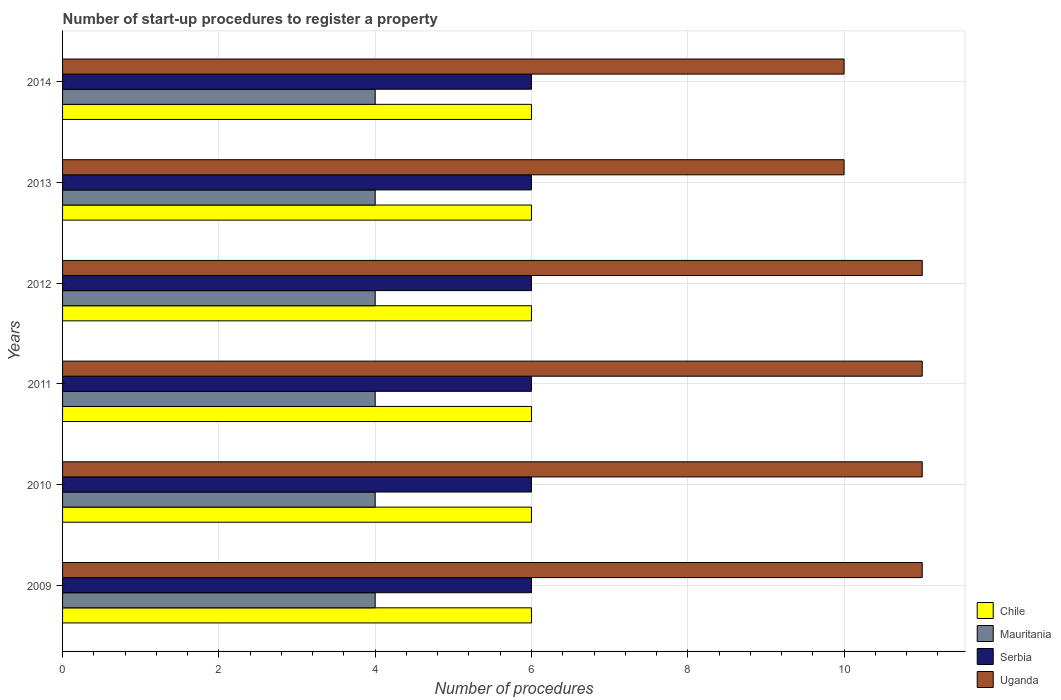How many groups of bars are there?
Keep it short and to the point. 6. Are the number of bars on each tick of the Y-axis equal?
Your answer should be very brief. Yes. How many bars are there on the 6th tick from the bottom?
Keep it short and to the point. 4. In how many cases, is the number of bars for a given year not equal to the number of legend labels?
Your answer should be very brief. 0. What is the number of procedures required to register a property in Mauritania in 2013?
Your answer should be very brief. 4. Across all years, what is the maximum number of procedures required to register a property in Uganda?
Your response must be concise. 11. Across all years, what is the minimum number of procedures required to register a property in Uganda?
Offer a terse response. 10. What is the total number of procedures required to register a property in Mauritania in the graph?
Offer a terse response. 24. What is the difference between the number of procedures required to register a property in Mauritania in 2011 and that in 2013?
Your answer should be compact. 0. What is the difference between the number of procedures required to register a property in Serbia in 2009 and the number of procedures required to register a property in Uganda in 2013?
Provide a succinct answer. -4. What is the average number of procedures required to register a property in Chile per year?
Provide a succinct answer. 6. In the year 2014, what is the difference between the number of procedures required to register a property in Chile and number of procedures required to register a property in Uganda?
Make the answer very short. -4. Is the difference between the number of procedures required to register a property in Chile in 2009 and 2012 greater than the difference between the number of procedures required to register a property in Uganda in 2009 and 2012?
Your response must be concise. No. What is the difference between the highest and the lowest number of procedures required to register a property in Uganda?
Make the answer very short. 1. Is the sum of the number of procedures required to register a property in Uganda in 2011 and 2013 greater than the maximum number of procedures required to register a property in Serbia across all years?
Provide a short and direct response. Yes. Is it the case that in every year, the sum of the number of procedures required to register a property in Serbia and number of procedures required to register a property in Chile is greater than the sum of number of procedures required to register a property in Mauritania and number of procedures required to register a property in Uganda?
Your answer should be very brief. No. What does the 1st bar from the top in 2011 represents?
Offer a terse response. Uganda. What does the 3rd bar from the bottom in 2009 represents?
Offer a terse response. Serbia. How many bars are there?
Keep it short and to the point. 24. Are all the bars in the graph horizontal?
Provide a short and direct response. Yes. Does the graph contain any zero values?
Your response must be concise. No. Does the graph contain grids?
Ensure brevity in your answer.  Yes. What is the title of the graph?
Offer a very short reply. Number of start-up procedures to register a property. What is the label or title of the X-axis?
Provide a short and direct response. Number of procedures. What is the Number of procedures in Chile in 2009?
Provide a short and direct response. 6. What is the Number of procedures of Serbia in 2009?
Make the answer very short. 6. What is the Number of procedures of Uganda in 2009?
Offer a very short reply. 11. What is the Number of procedures in Chile in 2010?
Keep it short and to the point. 6. What is the Number of procedures in Serbia in 2010?
Offer a terse response. 6. What is the Number of procedures in Chile in 2011?
Your answer should be very brief. 6. What is the Number of procedures in Serbia in 2011?
Give a very brief answer. 6. What is the Number of procedures of Uganda in 2011?
Offer a very short reply. 11. What is the Number of procedures of Chile in 2012?
Offer a very short reply. 6. What is the Number of procedures in Chile in 2013?
Your answer should be very brief. 6. What is the Number of procedures of Mauritania in 2013?
Keep it short and to the point. 4. What is the Number of procedures of Serbia in 2013?
Offer a terse response. 6. What is the Number of procedures of Uganda in 2013?
Provide a succinct answer. 10. What is the Number of procedures in Mauritania in 2014?
Offer a terse response. 4. What is the Number of procedures in Serbia in 2014?
Provide a succinct answer. 6. What is the Number of procedures in Uganda in 2014?
Your response must be concise. 10. Across all years, what is the maximum Number of procedures in Chile?
Offer a terse response. 6. Across all years, what is the maximum Number of procedures in Serbia?
Offer a terse response. 6. Across all years, what is the minimum Number of procedures in Chile?
Keep it short and to the point. 6. Across all years, what is the minimum Number of procedures in Mauritania?
Offer a very short reply. 4. What is the total Number of procedures of Chile in the graph?
Provide a succinct answer. 36. What is the total Number of procedures of Serbia in the graph?
Your response must be concise. 36. What is the total Number of procedures of Uganda in the graph?
Give a very brief answer. 64. What is the difference between the Number of procedures of Uganda in 2009 and that in 2010?
Provide a succinct answer. 0. What is the difference between the Number of procedures in Mauritania in 2009 and that in 2011?
Keep it short and to the point. 0. What is the difference between the Number of procedures in Mauritania in 2009 and that in 2012?
Your response must be concise. 0. What is the difference between the Number of procedures of Serbia in 2009 and that in 2012?
Keep it short and to the point. 0. What is the difference between the Number of procedures of Chile in 2009 and that in 2013?
Offer a very short reply. 0. What is the difference between the Number of procedures of Chile in 2009 and that in 2014?
Give a very brief answer. 0. What is the difference between the Number of procedures in Serbia in 2009 and that in 2014?
Offer a very short reply. 0. What is the difference between the Number of procedures in Uganda in 2009 and that in 2014?
Offer a very short reply. 1. What is the difference between the Number of procedures in Chile in 2010 and that in 2011?
Keep it short and to the point. 0. What is the difference between the Number of procedures of Serbia in 2010 and that in 2011?
Ensure brevity in your answer.  0. What is the difference between the Number of procedures of Uganda in 2010 and that in 2011?
Your response must be concise. 0. What is the difference between the Number of procedures of Chile in 2010 and that in 2012?
Offer a very short reply. 0. What is the difference between the Number of procedures of Chile in 2010 and that in 2013?
Your response must be concise. 0. What is the difference between the Number of procedures in Serbia in 2010 and that in 2013?
Provide a short and direct response. 0. What is the difference between the Number of procedures of Chile in 2010 and that in 2014?
Provide a short and direct response. 0. What is the difference between the Number of procedures of Mauritania in 2010 and that in 2014?
Offer a terse response. 0. What is the difference between the Number of procedures of Chile in 2011 and that in 2012?
Give a very brief answer. 0. What is the difference between the Number of procedures of Mauritania in 2011 and that in 2012?
Your answer should be very brief. 0. What is the difference between the Number of procedures in Uganda in 2011 and that in 2012?
Provide a succinct answer. 0. What is the difference between the Number of procedures of Mauritania in 2011 and that in 2013?
Offer a terse response. 0. What is the difference between the Number of procedures of Uganda in 2011 and that in 2013?
Offer a terse response. 1. What is the difference between the Number of procedures of Mauritania in 2011 and that in 2014?
Ensure brevity in your answer.  0. What is the difference between the Number of procedures in Mauritania in 2012 and that in 2013?
Provide a short and direct response. 0. What is the difference between the Number of procedures in Serbia in 2012 and that in 2013?
Your answer should be compact. 0. What is the difference between the Number of procedures of Uganda in 2012 and that in 2013?
Offer a very short reply. 1. What is the difference between the Number of procedures in Chile in 2012 and that in 2014?
Your answer should be compact. 0. What is the difference between the Number of procedures of Mauritania in 2013 and that in 2014?
Provide a succinct answer. 0. What is the difference between the Number of procedures of Serbia in 2013 and that in 2014?
Your answer should be compact. 0. What is the difference between the Number of procedures of Uganda in 2013 and that in 2014?
Provide a short and direct response. 0. What is the difference between the Number of procedures of Chile in 2009 and the Number of procedures of Mauritania in 2010?
Offer a very short reply. 2. What is the difference between the Number of procedures in Chile in 2009 and the Number of procedures in Serbia in 2010?
Your answer should be very brief. 0. What is the difference between the Number of procedures of Chile in 2009 and the Number of procedures of Uganda in 2010?
Offer a terse response. -5. What is the difference between the Number of procedures of Mauritania in 2009 and the Number of procedures of Serbia in 2010?
Provide a short and direct response. -2. What is the difference between the Number of procedures in Mauritania in 2009 and the Number of procedures in Serbia in 2011?
Your answer should be compact. -2. What is the difference between the Number of procedures in Mauritania in 2009 and the Number of procedures in Uganda in 2011?
Keep it short and to the point. -7. What is the difference between the Number of procedures in Chile in 2009 and the Number of procedures in Mauritania in 2012?
Your answer should be compact. 2. What is the difference between the Number of procedures in Chile in 2009 and the Number of procedures in Serbia in 2012?
Provide a short and direct response. 0. What is the difference between the Number of procedures of Chile in 2009 and the Number of procedures of Uganda in 2012?
Keep it short and to the point. -5. What is the difference between the Number of procedures in Mauritania in 2009 and the Number of procedures in Serbia in 2012?
Ensure brevity in your answer.  -2. What is the difference between the Number of procedures of Serbia in 2009 and the Number of procedures of Uganda in 2012?
Ensure brevity in your answer.  -5. What is the difference between the Number of procedures in Mauritania in 2009 and the Number of procedures in Serbia in 2013?
Make the answer very short. -2. What is the difference between the Number of procedures in Serbia in 2009 and the Number of procedures in Uganda in 2013?
Offer a terse response. -4. What is the difference between the Number of procedures of Mauritania in 2009 and the Number of procedures of Uganda in 2014?
Keep it short and to the point. -6. What is the difference between the Number of procedures in Serbia in 2009 and the Number of procedures in Uganda in 2014?
Provide a succinct answer. -4. What is the difference between the Number of procedures of Chile in 2010 and the Number of procedures of Mauritania in 2011?
Ensure brevity in your answer.  2. What is the difference between the Number of procedures in Mauritania in 2010 and the Number of procedures in Serbia in 2011?
Offer a terse response. -2. What is the difference between the Number of procedures in Serbia in 2010 and the Number of procedures in Uganda in 2011?
Your answer should be compact. -5. What is the difference between the Number of procedures in Chile in 2010 and the Number of procedures in Serbia in 2012?
Give a very brief answer. 0. What is the difference between the Number of procedures of Chile in 2010 and the Number of procedures of Uganda in 2012?
Your response must be concise. -5. What is the difference between the Number of procedures in Chile in 2010 and the Number of procedures in Mauritania in 2013?
Offer a terse response. 2. What is the difference between the Number of procedures of Chile in 2010 and the Number of procedures of Uganda in 2013?
Offer a terse response. -4. What is the difference between the Number of procedures of Mauritania in 2010 and the Number of procedures of Uganda in 2013?
Offer a terse response. -6. What is the difference between the Number of procedures of Serbia in 2010 and the Number of procedures of Uganda in 2013?
Provide a succinct answer. -4. What is the difference between the Number of procedures in Chile in 2010 and the Number of procedures in Uganda in 2014?
Provide a short and direct response. -4. What is the difference between the Number of procedures in Mauritania in 2010 and the Number of procedures in Serbia in 2014?
Provide a succinct answer. -2. What is the difference between the Number of procedures in Mauritania in 2010 and the Number of procedures in Uganda in 2014?
Give a very brief answer. -6. What is the difference between the Number of procedures in Chile in 2011 and the Number of procedures in Serbia in 2012?
Your answer should be compact. 0. What is the difference between the Number of procedures in Mauritania in 2011 and the Number of procedures in Serbia in 2012?
Keep it short and to the point. -2. What is the difference between the Number of procedures of Chile in 2011 and the Number of procedures of Serbia in 2013?
Your answer should be very brief. 0. What is the difference between the Number of procedures in Mauritania in 2011 and the Number of procedures in Serbia in 2013?
Offer a terse response. -2. What is the difference between the Number of procedures in Serbia in 2011 and the Number of procedures in Uganda in 2013?
Offer a terse response. -4. What is the difference between the Number of procedures in Chile in 2011 and the Number of procedures in Mauritania in 2014?
Your answer should be compact. 2. What is the difference between the Number of procedures in Chile in 2011 and the Number of procedures in Uganda in 2014?
Provide a succinct answer. -4. What is the difference between the Number of procedures of Mauritania in 2011 and the Number of procedures of Serbia in 2014?
Offer a very short reply. -2. What is the difference between the Number of procedures in Mauritania in 2011 and the Number of procedures in Uganda in 2014?
Your answer should be compact. -6. What is the difference between the Number of procedures in Serbia in 2011 and the Number of procedures in Uganda in 2014?
Your response must be concise. -4. What is the difference between the Number of procedures in Chile in 2012 and the Number of procedures in Mauritania in 2013?
Give a very brief answer. 2. What is the difference between the Number of procedures in Chile in 2012 and the Number of procedures in Serbia in 2013?
Your answer should be very brief. 0. What is the difference between the Number of procedures of Mauritania in 2012 and the Number of procedures of Serbia in 2013?
Provide a short and direct response. -2. What is the difference between the Number of procedures of Serbia in 2012 and the Number of procedures of Uganda in 2013?
Ensure brevity in your answer.  -4. What is the difference between the Number of procedures in Chile in 2012 and the Number of procedures in Uganda in 2014?
Ensure brevity in your answer.  -4. What is the difference between the Number of procedures in Mauritania in 2012 and the Number of procedures in Serbia in 2014?
Your answer should be compact. -2. What is the difference between the Number of procedures in Mauritania in 2012 and the Number of procedures in Uganda in 2014?
Your answer should be compact. -6. What is the difference between the Number of procedures in Chile in 2013 and the Number of procedures in Serbia in 2014?
Provide a short and direct response. 0. What is the difference between the Number of procedures of Chile in 2013 and the Number of procedures of Uganda in 2014?
Offer a terse response. -4. What is the difference between the Number of procedures of Mauritania in 2013 and the Number of procedures of Uganda in 2014?
Give a very brief answer. -6. What is the average Number of procedures in Uganda per year?
Provide a succinct answer. 10.67. In the year 2009, what is the difference between the Number of procedures in Chile and Number of procedures in Mauritania?
Your response must be concise. 2. In the year 2009, what is the difference between the Number of procedures in Chile and Number of procedures in Serbia?
Offer a very short reply. 0. In the year 2010, what is the difference between the Number of procedures of Chile and Number of procedures of Serbia?
Give a very brief answer. 0. In the year 2010, what is the difference between the Number of procedures in Mauritania and Number of procedures in Serbia?
Your answer should be compact. -2. In the year 2010, what is the difference between the Number of procedures in Serbia and Number of procedures in Uganda?
Provide a succinct answer. -5. In the year 2011, what is the difference between the Number of procedures in Chile and Number of procedures in Mauritania?
Ensure brevity in your answer.  2. In the year 2011, what is the difference between the Number of procedures of Chile and Number of procedures of Uganda?
Provide a succinct answer. -5. In the year 2011, what is the difference between the Number of procedures in Serbia and Number of procedures in Uganda?
Offer a terse response. -5. In the year 2012, what is the difference between the Number of procedures in Chile and Number of procedures in Mauritania?
Ensure brevity in your answer.  2. In the year 2012, what is the difference between the Number of procedures in Chile and Number of procedures in Serbia?
Provide a short and direct response. 0. In the year 2012, what is the difference between the Number of procedures of Mauritania and Number of procedures of Uganda?
Provide a short and direct response. -7. In the year 2012, what is the difference between the Number of procedures of Serbia and Number of procedures of Uganda?
Keep it short and to the point. -5. In the year 2013, what is the difference between the Number of procedures in Chile and Number of procedures in Serbia?
Provide a short and direct response. 0. In the year 2013, what is the difference between the Number of procedures of Chile and Number of procedures of Uganda?
Your answer should be compact. -4. In the year 2013, what is the difference between the Number of procedures in Mauritania and Number of procedures in Serbia?
Give a very brief answer. -2. In the year 2013, what is the difference between the Number of procedures in Serbia and Number of procedures in Uganda?
Keep it short and to the point. -4. What is the ratio of the Number of procedures in Mauritania in 2009 to that in 2010?
Your response must be concise. 1. What is the ratio of the Number of procedures in Serbia in 2009 to that in 2010?
Keep it short and to the point. 1. What is the ratio of the Number of procedures in Chile in 2009 to that in 2011?
Give a very brief answer. 1. What is the ratio of the Number of procedures in Mauritania in 2009 to that in 2011?
Keep it short and to the point. 1. What is the ratio of the Number of procedures of Uganda in 2009 to that in 2011?
Keep it short and to the point. 1. What is the ratio of the Number of procedures in Chile in 2009 to that in 2012?
Offer a very short reply. 1. What is the ratio of the Number of procedures of Serbia in 2009 to that in 2012?
Your response must be concise. 1. What is the ratio of the Number of procedures of Uganda in 2009 to that in 2012?
Offer a very short reply. 1. What is the ratio of the Number of procedures of Chile in 2009 to that in 2013?
Your answer should be very brief. 1. What is the ratio of the Number of procedures in Mauritania in 2009 to that in 2013?
Make the answer very short. 1. What is the ratio of the Number of procedures of Serbia in 2009 to that in 2013?
Your answer should be very brief. 1. What is the ratio of the Number of procedures of Uganda in 2009 to that in 2013?
Keep it short and to the point. 1.1. What is the ratio of the Number of procedures in Mauritania in 2009 to that in 2014?
Provide a succinct answer. 1. What is the ratio of the Number of procedures of Serbia in 2009 to that in 2014?
Keep it short and to the point. 1. What is the ratio of the Number of procedures of Mauritania in 2010 to that in 2012?
Make the answer very short. 1. What is the ratio of the Number of procedures of Uganda in 2010 to that in 2012?
Provide a succinct answer. 1. What is the ratio of the Number of procedures of Serbia in 2010 to that in 2013?
Your answer should be compact. 1. What is the ratio of the Number of procedures of Chile in 2010 to that in 2014?
Your response must be concise. 1. What is the ratio of the Number of procedures in Uganda in 2010 to that in 2014?
Give a very brief answer. 1.1. What is the ratio of the Number of procedures in Chile in 2011 to that in 2012?
Ensure brevity in your answer.  1. What is the ratio of the Number of procedures of Serbia in 2011 to that in 2012?
Provide a short and direct response. 1. What is the ratio of the Number of procedures in Uganda in 2011 to that in 2012?
Your answer should be compact. 1. What is the ratio of the Number of procedures of Chile in 2011 to that in 2013?
Ensure brevity in your answer.  1. What is the ratio of the Number of procedures in Serbia in 2011 to that in 2013?
Ensure brevity in your answer.  1. What is the ratio of the Number of procedures of Uganda in 2011 to that in 2013?
Provide a succinct answer. 1.1. What is the ratio of the Number of procedures of Chile in 2011 to that in 2014?
Provide a succinct answer. 1. What is the ratio of the Number of procedures in Mauritania in 2011 to that in 2014?
Keep it short and to the point. 1. What is the ratio of the Number of procedures of Uganda in 2011 to that in 2014?
Give a very brief answer. 1.1. What is the ratio of the Number of procedures of Serbia in 2012 to that in 2013?
Your answer should be compact. 1. What is the ratio of the Number of procedures in Uganda in 2012 to that in 2013?
Offer a terse response. 1.1. What is the ratio of the Number of procedures in Mauritania in 2012 to that in 2014?
Your response must be concise. 1. What is the ratio of the Number of procedures in Chile in 2013 to that in 2014?
Ensure brevity in your answer.  1. What is the ratio of the Number of procedures in Mauritania in 2013 to that in 2014?
Offer a terse response. 1. What is the ratio of the Number of procedures of Serbia in 2013 to that in 2014?
Make the answer very short. 1. What is the ratio of the Number of procedures in Uganda in 2013 to that in 2014?
Your response must be concise. 1. What is the difference between the highest and the second highest Number of procedures of Chile?
Your answer should be very brief. 0. What is the difference between the highest and the second highest Number of procedures of Mauritania?
Provide a short and direct response. 0. What is the difference between the highest and the second highest Number of procedures of Uganda?
Keep it short and to the point. 0. What is the difference between the highest and the lowest Number of procedures of Uganda?
Your answer should be compact. 1. 